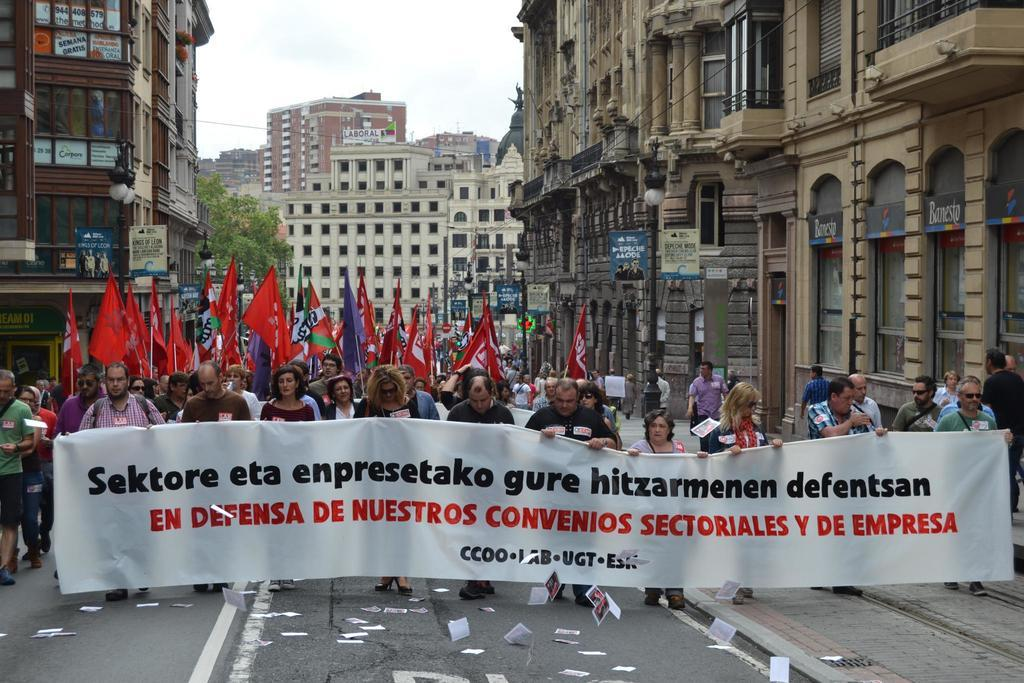How many people are present in the image? There are many people in the image. What are some people holding in the image? Some people are holding a banner and flags in the image. What type of structures can be seen in the image? There are buildings in the image. What other natural elements are present in the image? There are trees in the image. What is visible in the background of the image? The sky is visible in the image. Can you see the brother's ring on his ear in the image? There is no brother or ring on anyone's ear present in the image. 